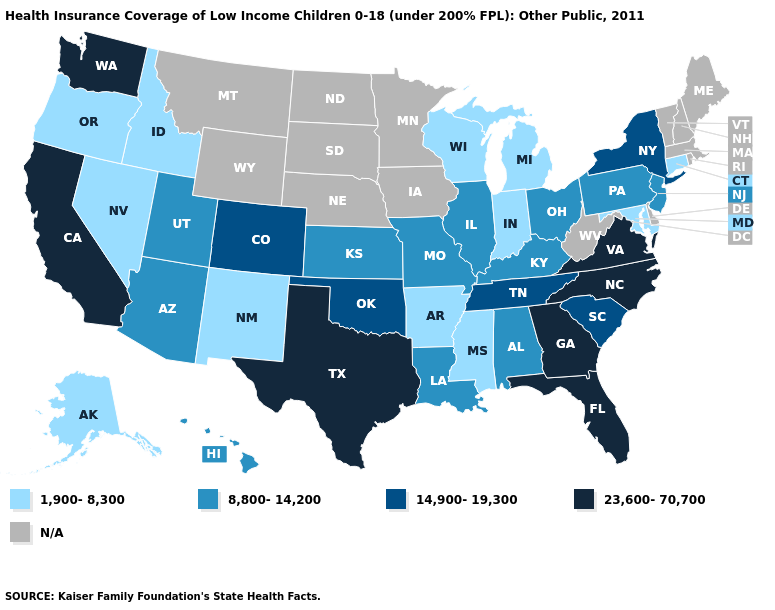Name the states that have a value in the range 23,600-70,700?
Short answer required. California, Florida, Georgia, North Carolina, Texas, Virginia, Washington. Name the states that have a value in the range 14,900-19,300?
Answer briefly. Colorado, New York, Oklahoma, South Carolina, Tennessee. Name the states that have a value in the range 23,600-70,700?
Short answer required. California, Florida, Georgia, North Carolina, Texas, Virginia, Washington. Among the states that border Wyoming , does Colorado have the lowest value?
Give a very brief answer. No. How many symbols are there in the legend?
Concise answer only. 5. Which states have the highest value in the USA?
Give a very brief answer. California, Florida, Georgia, North Carolina, Texas, Virginia, Washington. What is the value of Delaware?
Write a very short answer. N/A. What is the value of Utah?
Quick response, please. 8,800-14,200. Which states have the lowest value in the South?
Short answer required. Arkansas, Maryland, Mississippi. Name the states that have a value in the range N/A?
Be succinct. Delaware, Iowa, Maine, Massachusetts, Minnesota, Montana, Nebraska, New Hampshire, North Dakota, Rhode Island, South Dakota, Vermont, West Virginia, Wyoming. What is the value of Louisiana?
Short answer required. 8,800-14,200. What is the value of New Mexico?
Answer briefly. 1,900-8,300. Does Tennessee have the lowest value in the USA?
Concise answer only. No. 